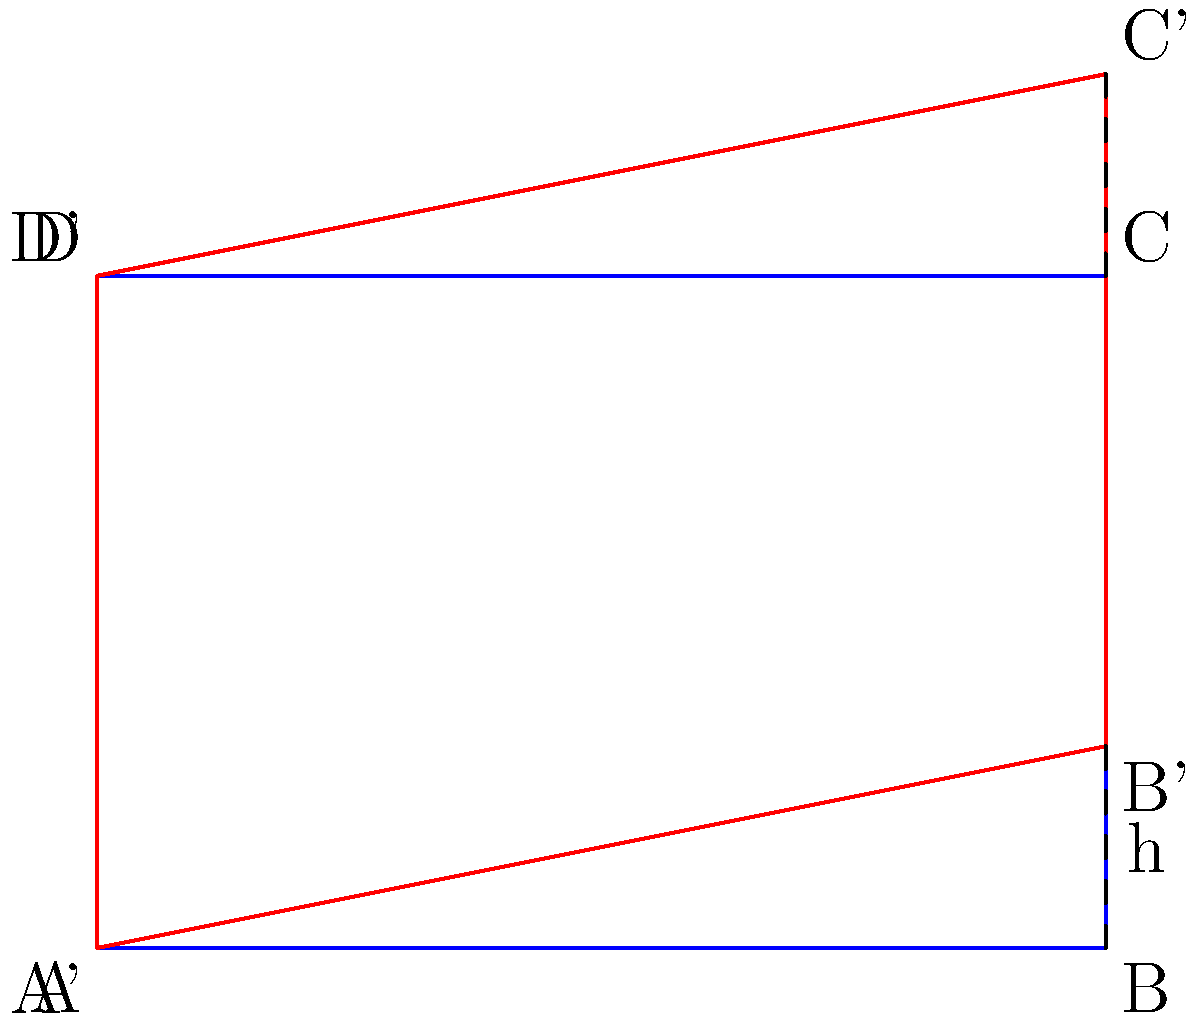A rectangular hydrogel structure with dimensions 3 cm × 2 cm is subjected to a shear deformation to mimic natural tissue behavior. The top edge of the structure is displaced horizontally by 0.6 cm while the bottom edge remains fixed. Calculate the shear strain $\gamma$ experienced by the hydrogel structure. To solve this problem, we need to follow these steps:

1. Understand the definition of shear strain:
   Shear strain $\gamma$ is defined as the ratio of the horizontal displacement to the height of the structure.

2. Identify the given information:
   - Height of the structure: $h = 2$ cm
   - Horizontal displacement: $d = 0.6$ cm

3. Apply the formula for shear strain:
   $$\gamma = \frac{d}{h}$$

4. Substitute the values:
   $$\gamma = \frac{0.6 \text{ cm}}{2 \text{ cm}}$$

5. Calculate the result:
   $$\gamma = 0.3$$

6. Express the result as a unitless ratio or percentage:
   The shear strain is 0.3 or 30%.
Answer: 0.3 or 30% 